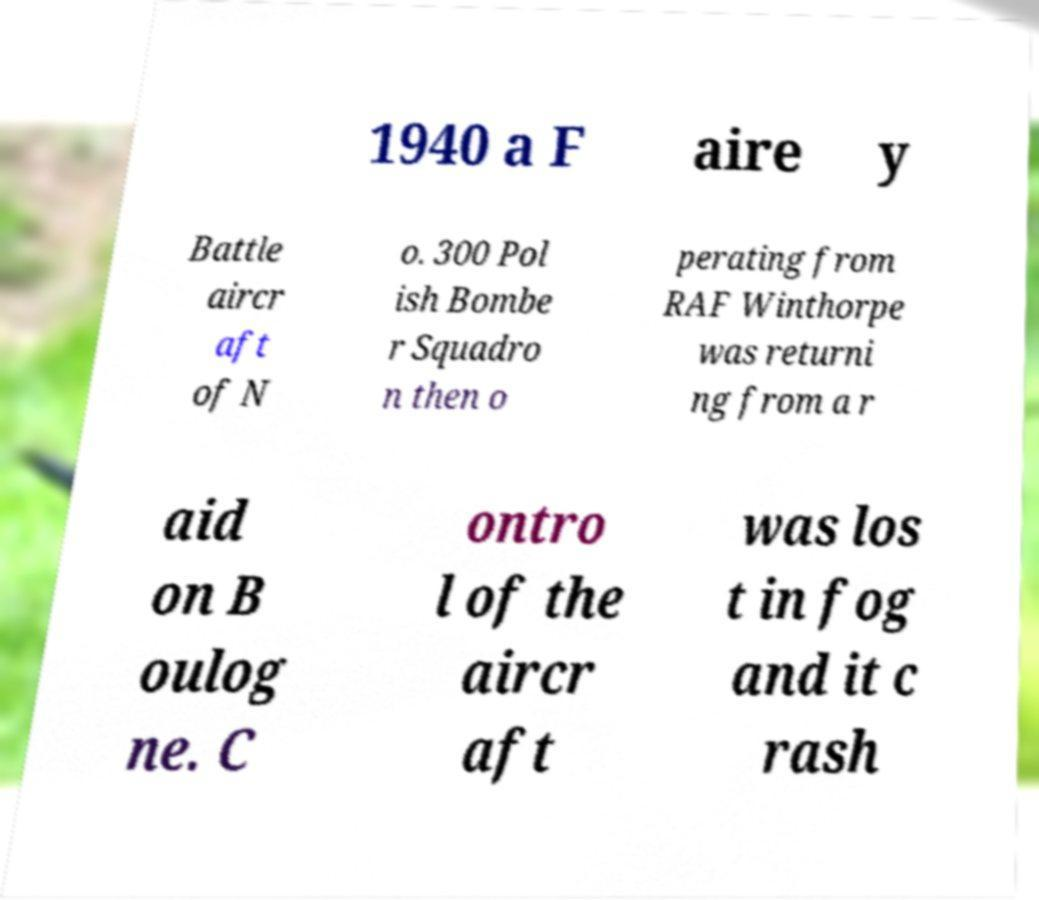What messages or text are displayed in this image? I need them in a readable, typed format. 1940 a F aire y Battle aircr aft of N o. 300 Pol ish Bombe r Squadro n then o perating from RAF Winthorpe was returni ng from a r aid on B oulog ne. C ontro l of the aircr aft was los t in fog and it c rash 